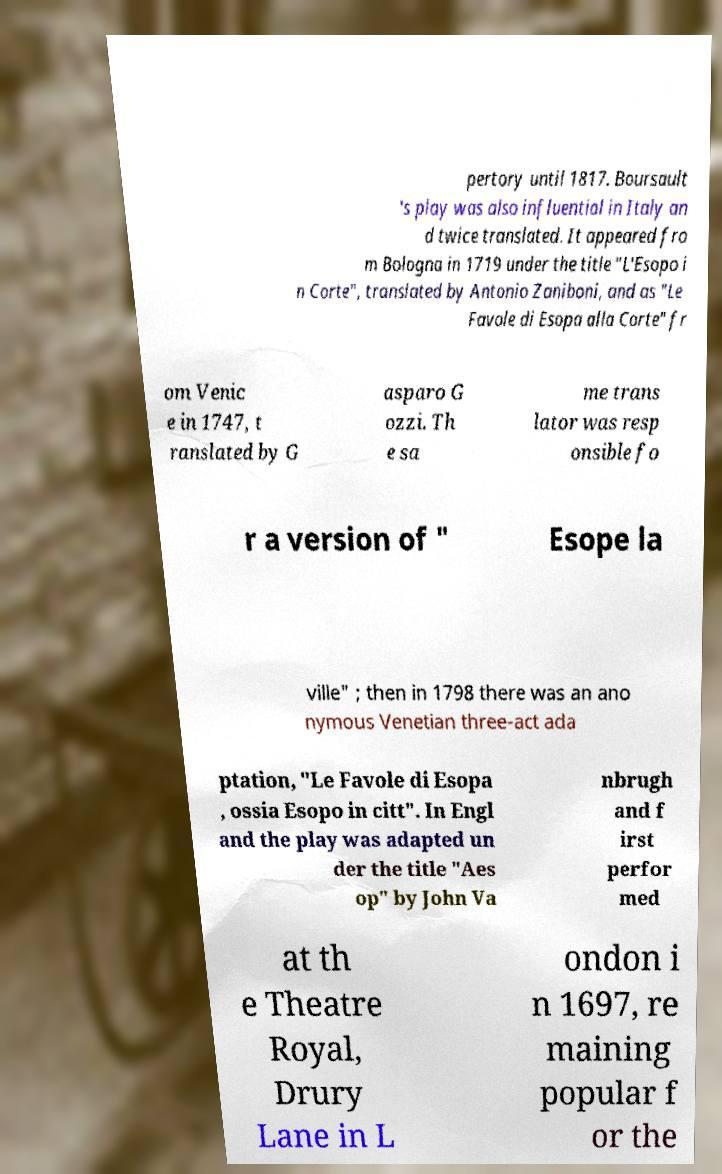Please identify and transcribe the text found in this image. pertory until 1817. Boursault 's play was also influential in Italy an d twice translated. It appeared fro m Bologna in 1719 under the title "L'Esopo i n Corte", translated by Antonio Zaniboni, and as "Le Favole di Esopa alla Corte" fr om Venic e in 1747, t ranslated by G asparo G ozzi. Th e sa me trans lator was resp onsible fo r a version of " Esope la ville" ; then in 1798 there was an ano nymous Venetian three-act ada ptation, "Le Favole di Esopa , ossia Esopo in citt". In Engl and the play was adapted un der the title "Aes op" by John Va nbrugh and f irst perfor med at th e Theatre Royal, Drury Lane in L ondon i n 1697, re maining popular f or the 